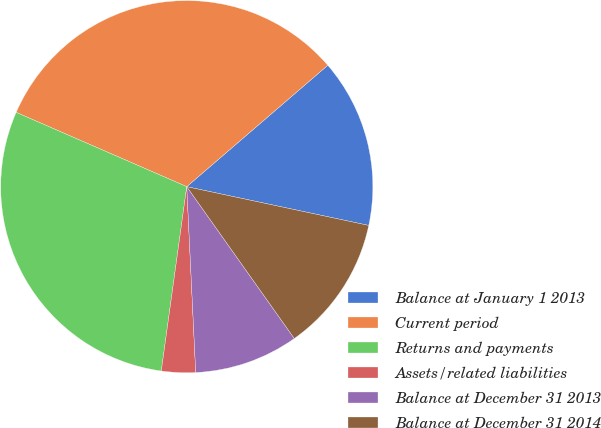Convert chart. <chart><loc_0><loc_0><loc_500><loc_500><pie_chart><fcel>Balance at January 1 2013<fcel>Current period<fcel>Returns and payments<fcel>Assets/related liabilities<fcel>Balance at December 31 2013<fcel>Balance at December 31 2014<nl><fcel>14.65%<fcel>32.15%<fcel>29.35%<fcel>2.95%<fcel>9.04%<fcel>11.85%<nl></chart> 